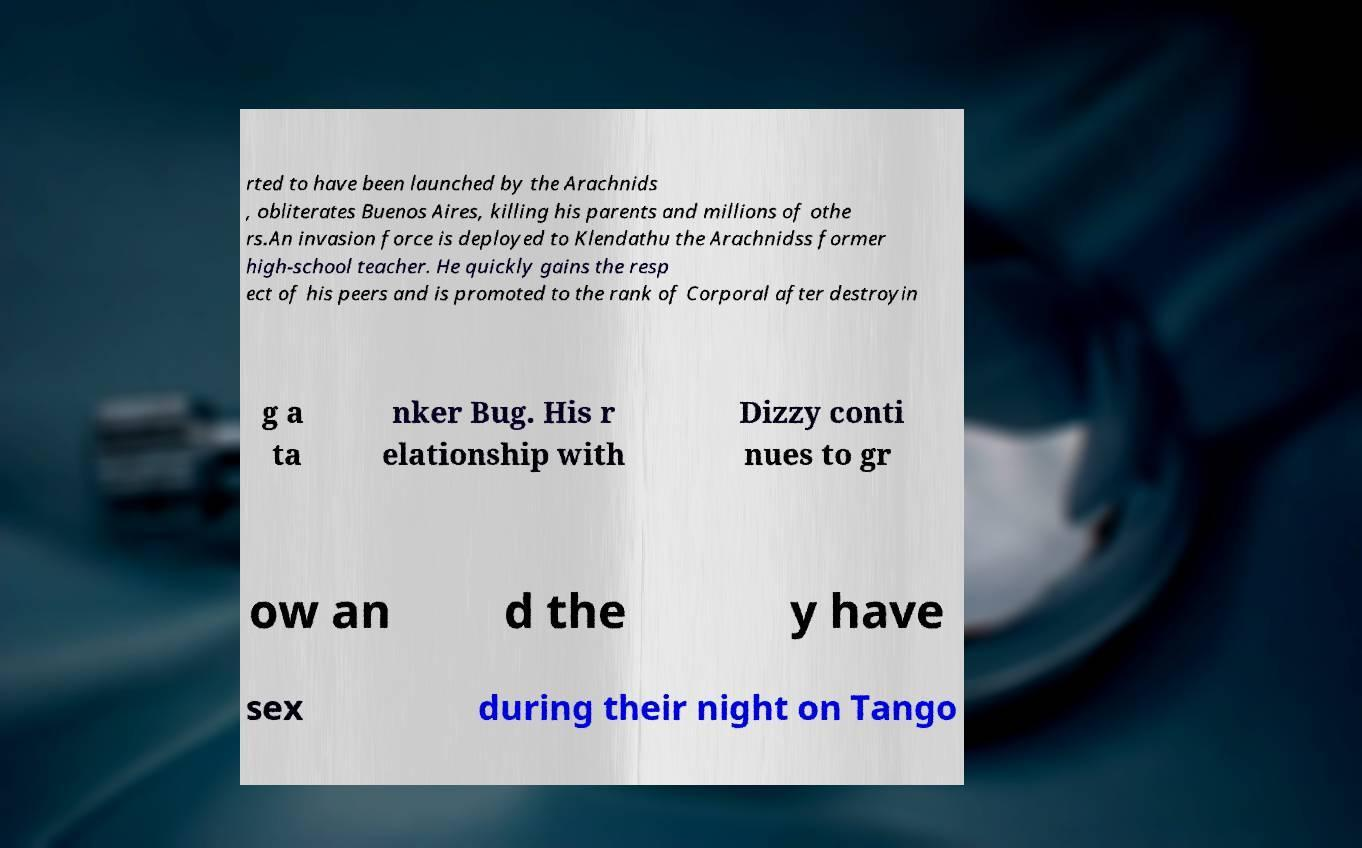There's text embedded in this image that I need extracted. Can you transcribe it verbatim? rted to have been launched by the Arachnids , obliterates Buenos Aires, killing his parents and millions of othe rs.An invasion force is deployed to Klendathu the Arachnidss former high-school teacher. He quickly gains the resp ect of his peers and is promoted to the rank of Corporal after destroyin g a ta nker Bug. His r elationship with Dizzy conti nues to gr ow an d the y have sex during their night on Tango 